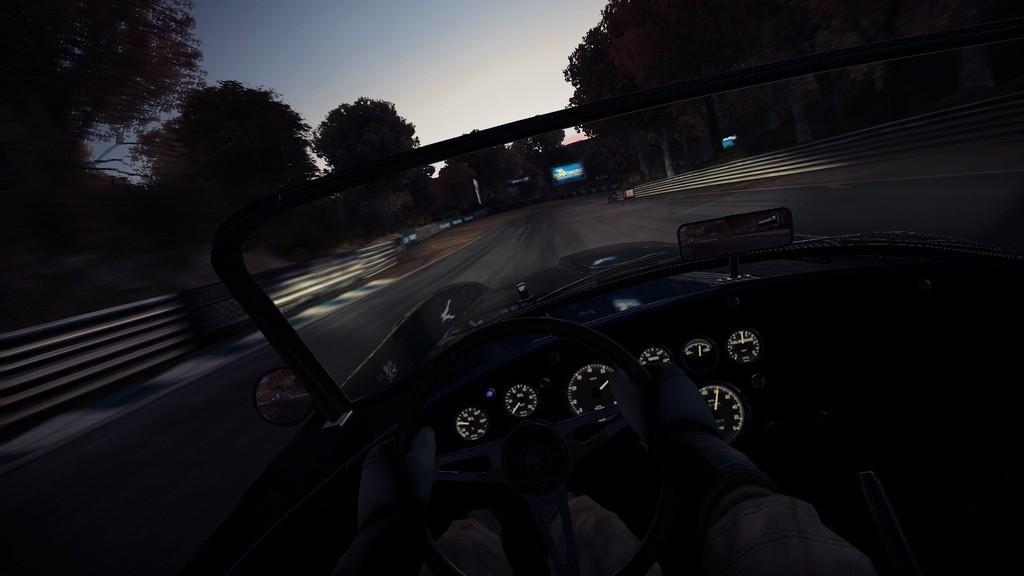In one or two sentences, can you explain what this image depicts? The image is taken in the nighttime. In this image there is a car on the road. There is a person sitting in the car by holding the steering. There are trees on either side of the road. At the top there is sky. In front of the car there is a hoarding. 